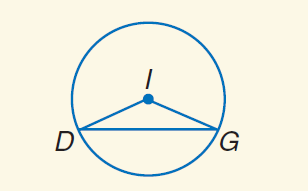Answer the mathemtical geometry problem and directly provide the correct option letter.
Question: Find \widehat D G if m \angle D G I = 24 and r = 6.
Choices: A: 6 B: \frac { 22 } { 5 } \pi C: 24 D: 24 \pi B 